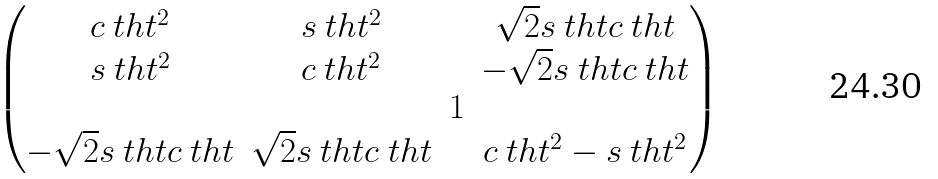Convert formula to latex. <formula><loc_0><loc_0><loc_500><loc_500>\begin{pmatrix} c _ { \ } t h t ^ { 2 } & s _ { \ } t h t ^ { 2 } & & \sqrt { 2 } s _ { \ } t h t c _ { \ } t h t \\ s _ { \ } t h t ^ { 2 } & c _ { \ } t h t ^ { 2 } & & - \sqrt { 2 } s _ { \ } t h t c _ { \ } t h t \\ & & 1 & \\ - \sqrt { 2 } s _ { \ } t h t c _ { \ } t h t & \sqrt { 2 } s _ { \ } t h t c _ { \ } t h t & & c _ { \ } t h t ^ { 2 } - s _ { \ } t h t ^ { 2 } \end{pmatrix}</formula> 